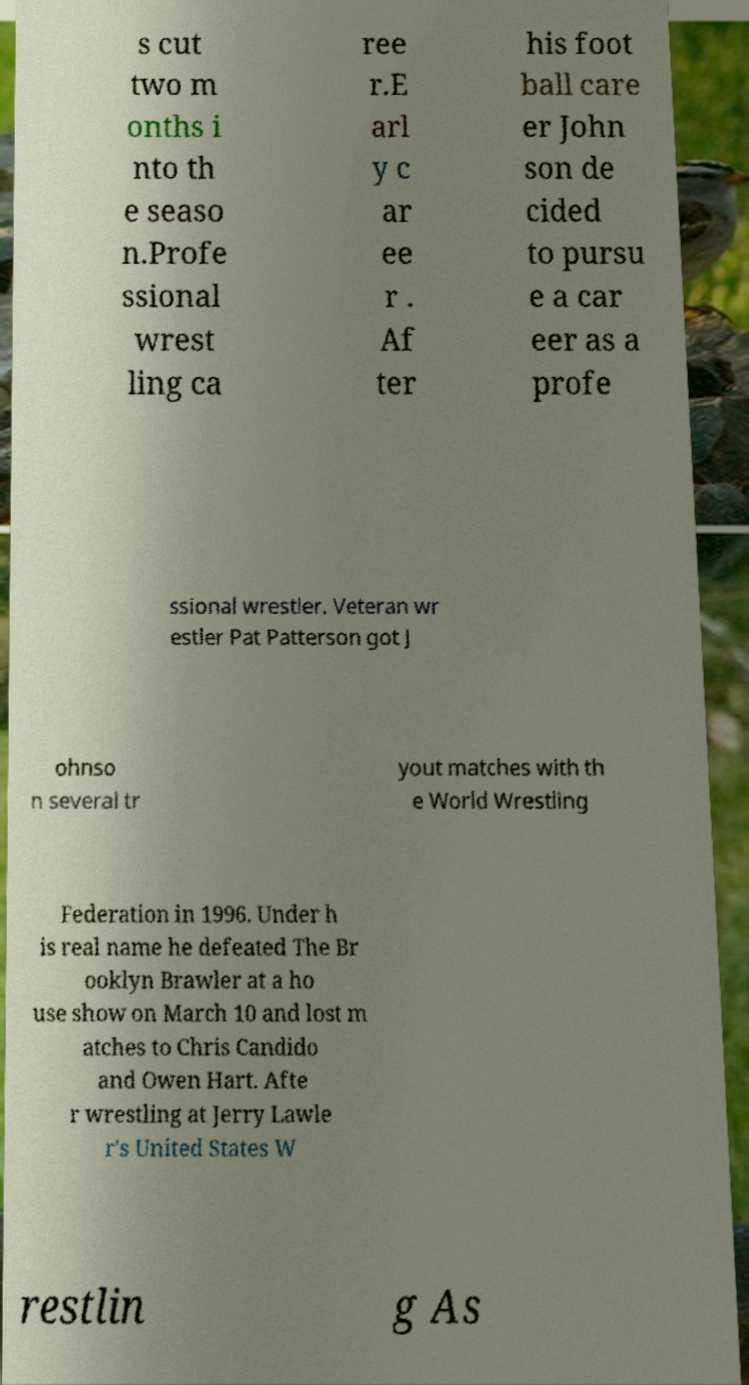I need the written content from this picture converted into text. Can you do that? s cut two m onths i nto th e seaso n.Profe ssional wrest ling ca ree r.E arl y c ar ee r . Af ter his foot ball care er John son de cided to pursu e a car eer as a profe ssional wrestler. Veteran wr estler Pat Patterson got J ohnso n several tr yout matches with th e World Wrestling Federation in 1996. Under h is real name he defeated The Br ooklyn Brawler at a ho use show on March 10 and lost m atches to Chris Candido and Owen Hart. Afte r wrestling at Jerry Lawle r's United States W restlin g As 